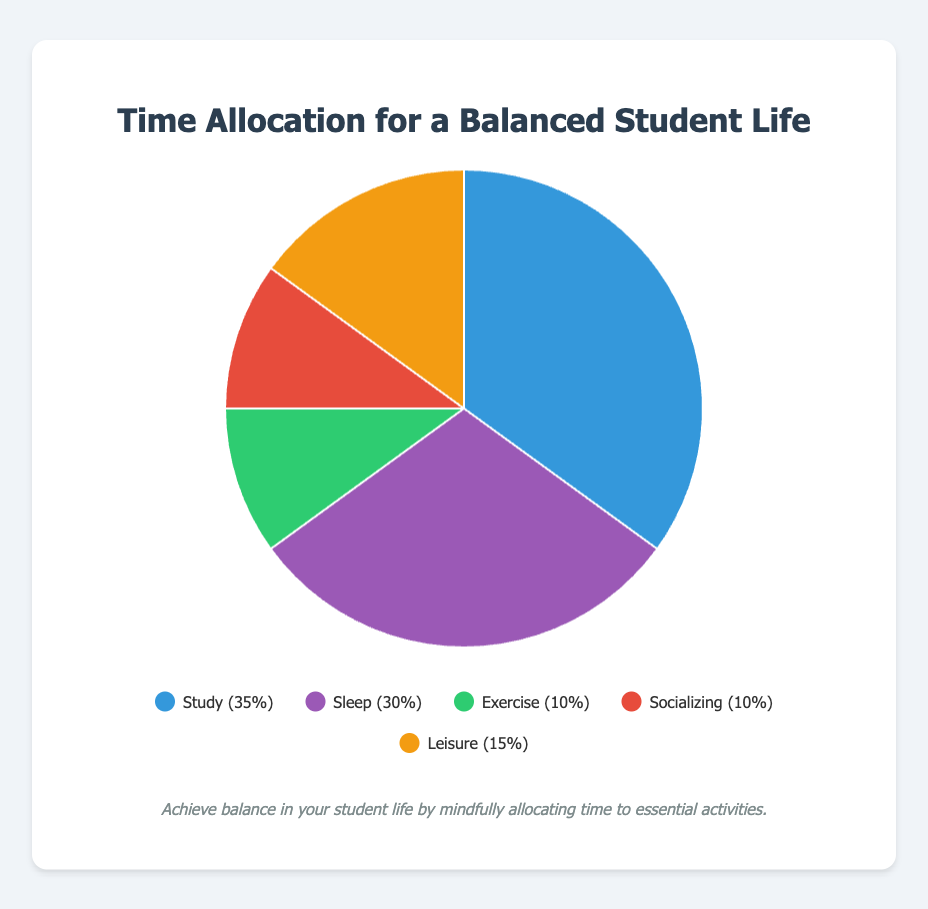What percentage of time is allocated to Study compared to Sleep? Study is allocated 35% of the time, while Sleep is allocated 30%. By comparing these percentages, Study is allocated 5% more time than Sleep.
Answer: 5% more Which activities have an equal percentage of time allocation, and what is their shared percentage? Exercise and Socializing both have a time allocation of 10%. By visually inspecting the pie chart, it can be confirmed that these two activities share the same percentage.
Answer: Exercise and Socializing, 10% If you combine the time allocated to Exercise and Socializing, what percentage of the total time does that represent? Exercise is 10% and Socializing is 10%. Adding them together gives 10% + 10% = 20%.
Answer: 20% What is the least time-consuming activity, and how much time is allocated to it in hours per week? Visual inspection of the pie chart shows that both Exercise and Socializing are at 10%, the lowest percentage. Since each represents 10% of the 168 hours in a week, that's 10/100 * 168 = 16.8 hours for each. The description states 10 hours recommended for Exercise, confirming it's the least.
Answer: Exercise, 10 hours per week If a student wants to balance their time effectively, how many hours per week should be allocated to Leisure? Leisure is allocated 15% of the total time. To find hours per week, take 15/100 * 168 hours = 25.2 hours per week. The description also recommended 15 hours, showing effective balance.
Answer: 15 hours per week Without reading the labels, what activity is represented by the color blue, and how much time is allocated to it in percentage? By visual inspection of the chart, the color blue is associated with Study. The time allocation for Study is 35%.
Answer: Study, 35% If we add the time allocated for Study and Sleep, what is the total percentage of time these two activities represent? Study is 35% and Sleep is 30%. Adding these together gives 35% + 30% = 65%.
Answer: 65% Which category has more time allocated: Leisure or Exercise, and by how much? Leisure has 15% allocated, whereas Exercise has 10% allocated. The difference is 15% - 10% = 5%.
Answer: Leisure, 5% more What is the combined percentage of time for activities related to physical and mental well-being (Sleep, Exercise, Leisure)? Sleep is 30%, Exercise is 10%, and Leisure is 15%. Adding these together gives 30% + 10% + 15% = 55%.
Answer: 55% How does the time allocated to Socializing compare with the time allocated to Sleep in terms of percentage? Socializing is allocated 10% of the time, while Sleep is allocated 30%. Sleep has 30% - 10% = 20% more time allocated than Socializing.
Answer: Sleep, 20% more 